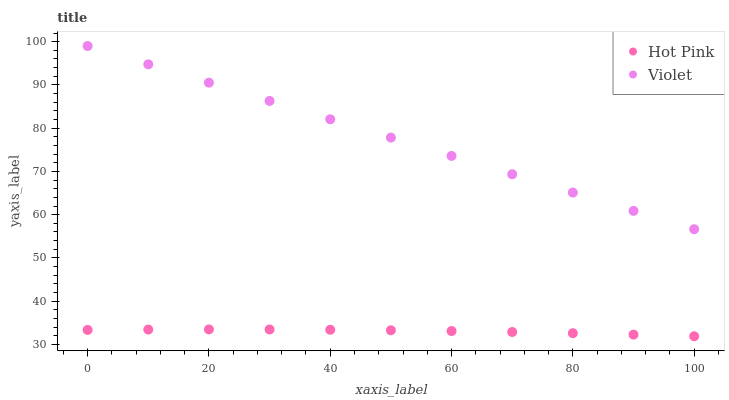Does Hot Pink have the minimum area under the curve?
Answer yes or no. Yes. Does Violet have the maximum area under the curve?
Answer yes or no. Yes. Does Violet have the minimum area under the curve?
Answer yes or no. No. Is Violet the smoothest?
Answer yes or no. Yes. Is Hot Pink the roughest?
Answer yes or no. Yes. Is Violet the roughest?
Answer yes or no. No. Does Hot Pink have the lowest value?
Answer yes or no. Yes. Does Violet have the lowest value?
Answer yes or no. No. Does Violet have the highest value?
Answer yes or no. Yes. Is Hot Pink less than Violet?
Answer yes or no. Yes. Is Violet greater than Hot Pink?
Answer yes or no. Yes. Does Hot Pink intersect Violet?
Answer yes or no. No. 